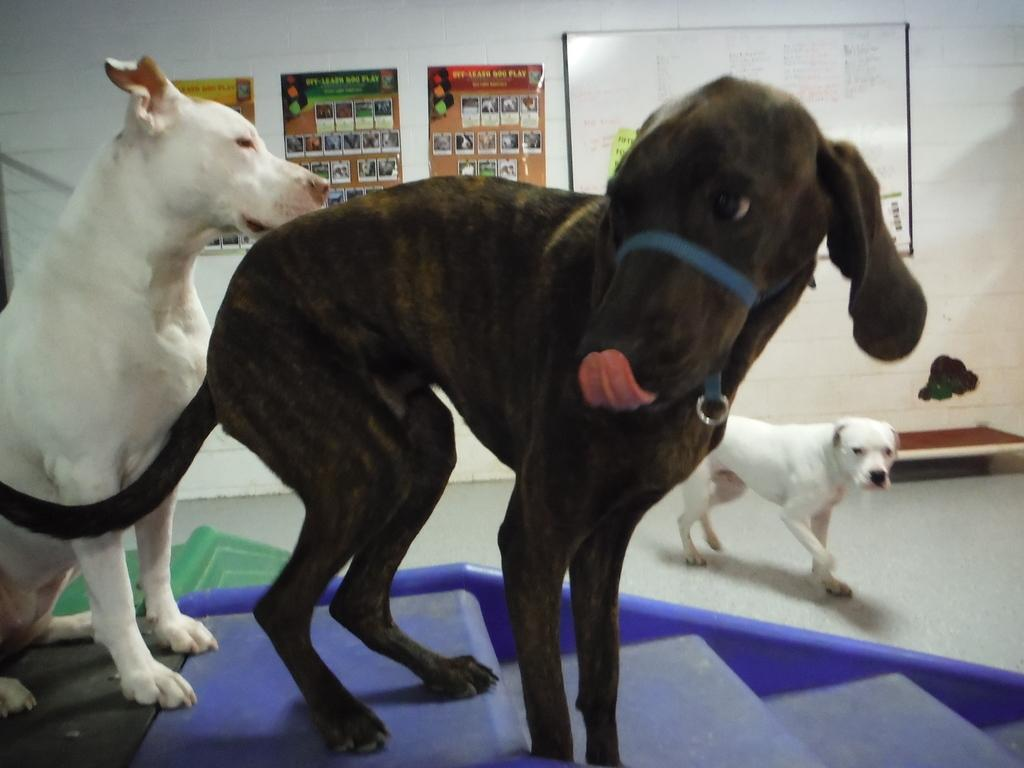How many dogs are visible in the image? There are three dogs visible in the image. Where are the dogs located in the image? Two dogs are on the stairs, and one dog is on the floor. What furniture is present in the image? There is a table in the image. What can be seen on the wall in the image? There are papers pasted on the wall. What other object is present in the image? There is a board in the image. What type of meat is being used for the match on the board in the image? There is no match or board game present in the image, and no meat is mentioned or visible. 